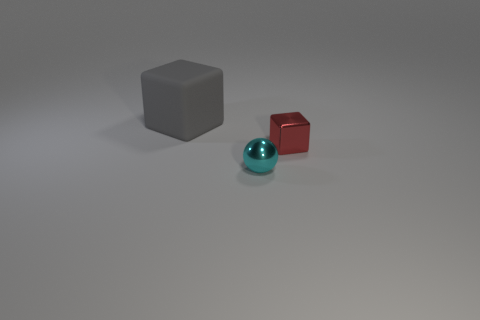Is there any other thing that has the same material as the big gray block?
Your response must be concise. No. There is a metallic object right of the cyan metallic thing; what number of tiny metal spheres are in front of it?
Give a very brief answer. 1. There is a object that is made of the same material as the small cyan sphere; what shape is it?
Make the answer very short. Cube. How many gray objects are either matte cubes or blocks?
Provide a short and direct response. 1. There is a block that is left of the small shiny object to the right of the cyan ball; are there any cyan things behind it?
Your answer should be very brief. No. Are there fewer small cyan cubes than small metal objects?
Your response must be concise. Yes. Is the shape of the thing to the left of the cyan metallic sphere the same as  the red object?
Provide a succinct answer. Yes. Are any small cyan things visible?
Your response must be concise. Yes. What color is the metallic thing right of the cyan ball that is in front of the tiny thing to the right of the small ball?
Your answer should be very brief. Red. Is the number of big gray cubes in front of the red metal block the same as the number of gray objects behind the large matte cube?
Offer a terse response. Yes. 